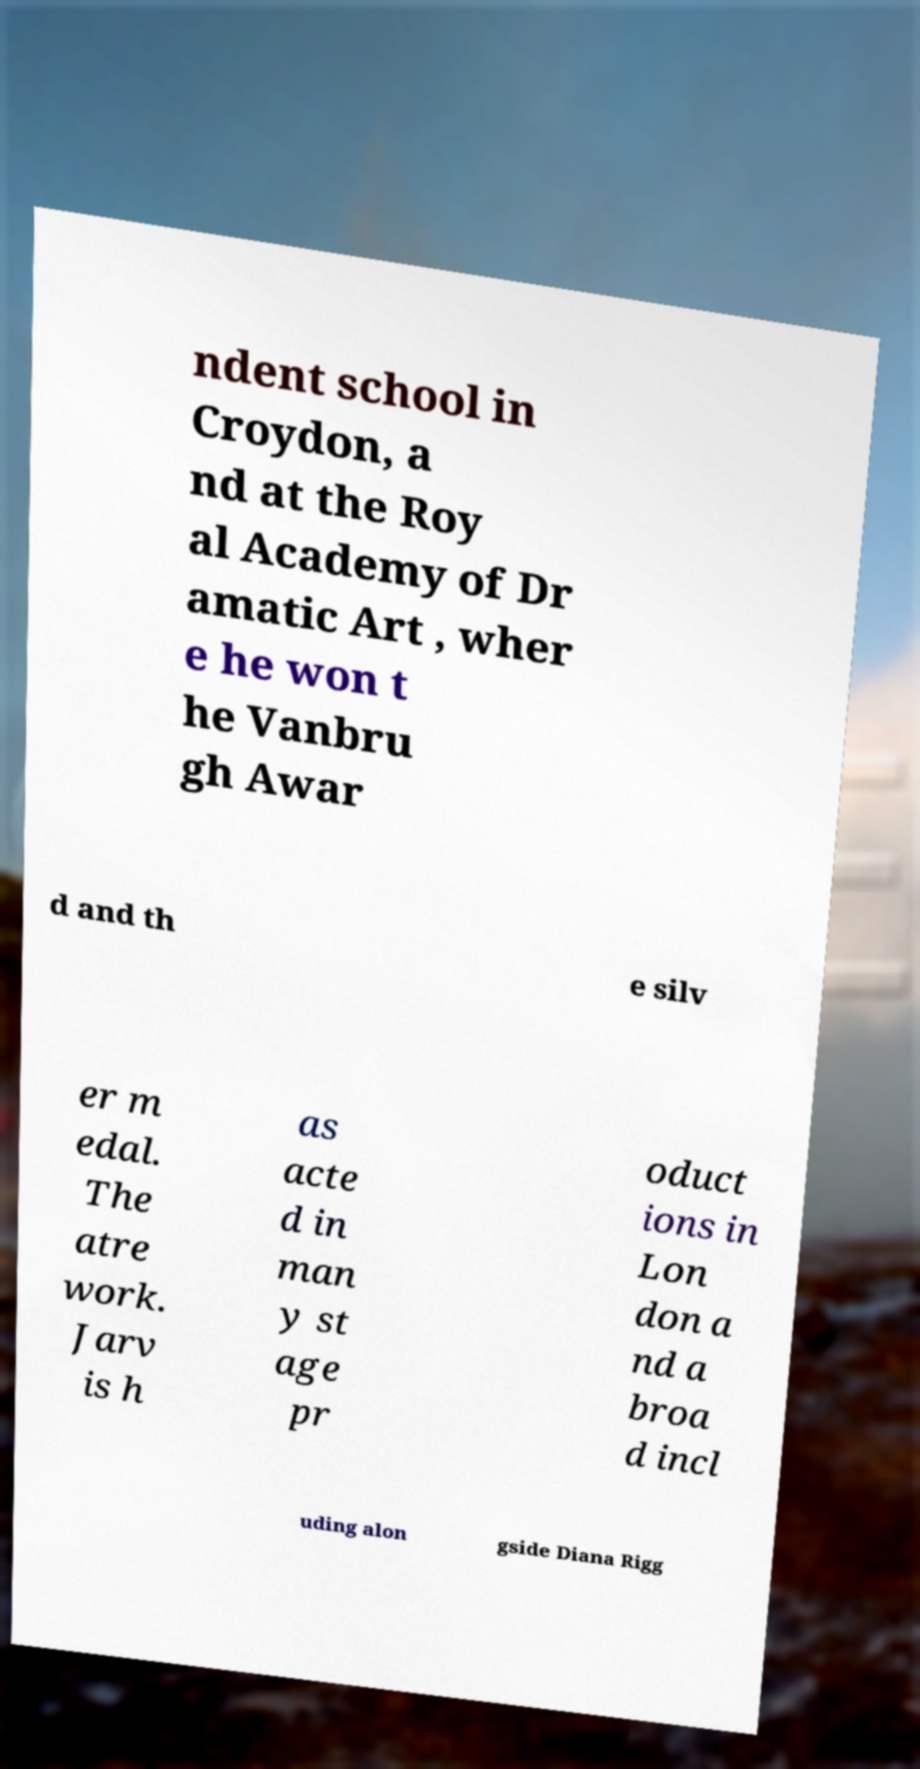Please identify and transcribe the text found in this image. ndent school in Croydon, a nd at the Roy al Academy of Dr amatic Art , wher e he won t he Vanbru gh Awar d and th e silv er m edal. The atre work. Jarv is h as acte d in man y st age pr oduct ions in Lon don a nd a broa d incl uding alon gside Diana Rigg 